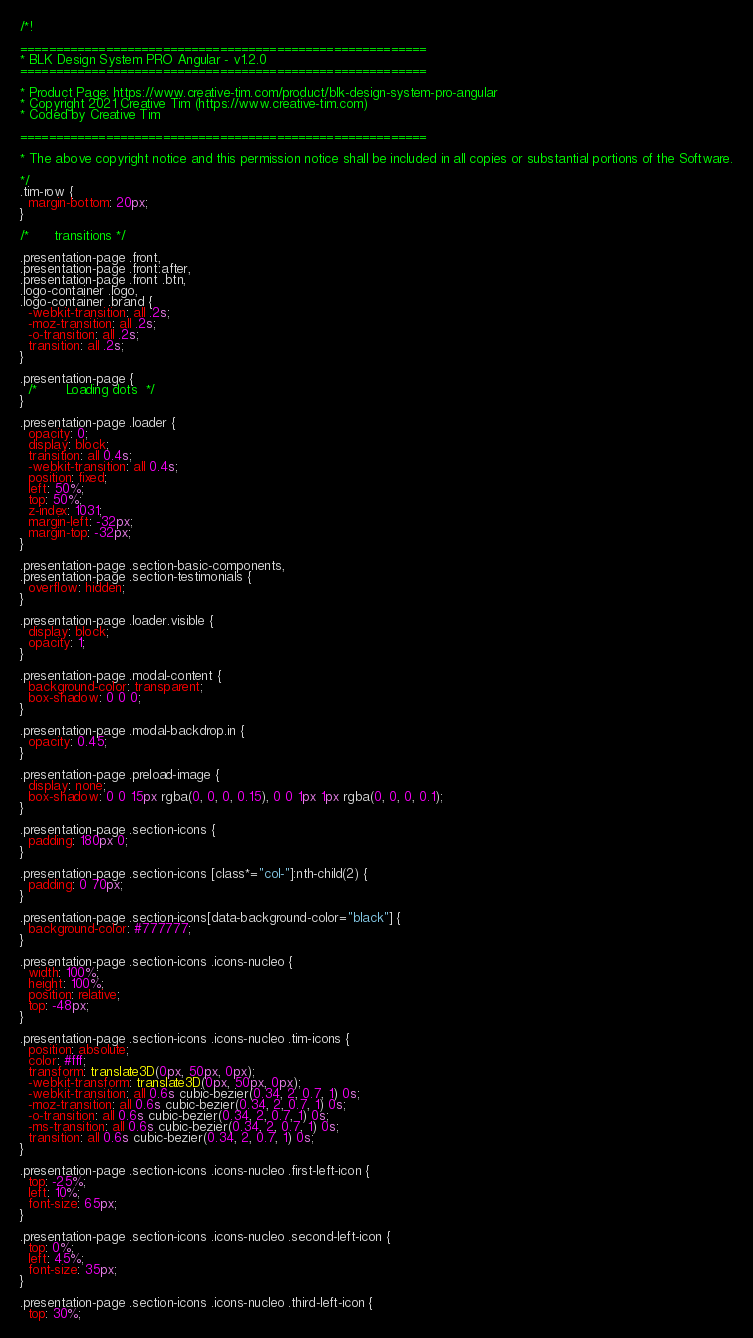Convert code to text. <code><loc_0><loc_0><loc_500><loc_500><_CSS_>/*!

=========================================================
* BLK Design System PRO Angular - v1.2.0
=========================================================

* Product Page: https://www.creative-tim.com/product/blk-design-system-pro-angular
* Copyright 2021 Creative Tim (https://www.creative-tim.com)
* Coded by Creative Tim

=========================================================

* The above copyright notice and this permission notice shall be included in all copies or substantial portions of the Software.

*/
.tim-row {
  margin-bottom: 20px;
}

/*      transitions */

.presentation-page .front,
.presentation-page .front:after,
.presentation-page .front .btn,
.logo-container .logo,
.logo-container .brand {
  -webkit-transition: all .2s;
  -moz-transition: all .2s;
  -o-transition: all .2s;
  transition: all .2s;
}

.presentation-page {
  /*       Loading dots  */
}

.presentation-page .loader {
  opacity: 0;
  display: block;
  transition: all 0.4s;
  -webkit-transition: all 0.4s;
  position: fixed;
  left: 50%;
  top: 50%;
  z-index: 1031;
  margin-left: -32px;
  margin-top: -32px;
}

.presentation-page .section-basic-components,
.presentation-page .section-testimonials {
  overflow: hidden;
}

.presentation-page .loader.visible {
  display: block;
  opacity: 1;
}

.presentation-page .modal-content {
  background-color: transparent;
  box-shadow: 0 0 0;
}

.presentation-page .modal-backdrop.in {
  opacity: 0.45;
}

.presentation-page .preload-image {
  display: none;
  box-shadow: 0 0 15px rgba(0, 0, 0, 0.15), 0 0 1px 1px rgba(0, 0, 0, 0.1);
}

.presentation-page .section-icons {
  padding: 180px 0;
}

.presentation-page .section-icons [class*="col-"]:nth-child(2) {
  padding: 0 70px;
}

.presentation-page .section-icons[data-background-color="black"] {
  background-color: #777777;
}

.presentation-page .section-icons .icons-nucleo {
  width: 100%;
  height: 100%;
  position: relative;
  top: -48px;
}

.presentation-page .section-icons .icons-nucleo .tim-icons {
  position: absolute;
  color: #fff;
  transform: translate3D(0px, 50px, 0px);
  -webkit-transform: translate3D(0px, 50px, 0px);
  -webkit-transition: all 0.6s cubic-bezier(0.34, 2, 0.7, 1) 0s;
  -moz-transition: all 0.6s cubic-bezier(0.34, 2, 0.7, 1) 0s;
  -o-transition: all 0.6s cubic-bezier(0.34, 2, 0.7, 1) 0s;
  -ms-transition: all 0.6s cubic-bezier(0.34, 2, 0.7, 1) 0s;
  transition: all 0.6s cubic-bezier(0.34, 2, 0.7, 1) 0s;
}

.presentation-page .section-icons .icons-nucleo .first-left-icon {
  top: -25%;
  left: 10%;
  font-size: 65px;
}

.presentation-page .section-icons .icons-nucleo .second-left-icon {
  top: 0%;
  left: 45%;
  font-size: 35px;
}

.presentation-page .section-icons .icons-nucleo .third-left-icon {
  top: 30%;</code> 